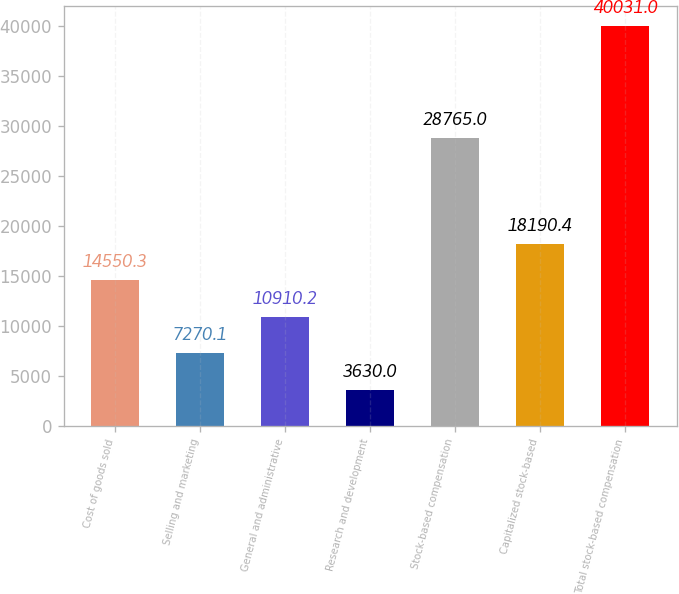Convert chart to OTSL. <chart><loc_0><loc_0><loc_500><loc_500><bar_chart><fcel>Cost of goods sold<fcel>Selling and marketing<fcel>General and administrative<fcel>Research and development<fcel>Stock-based compensation<fcel>Capitalized stock-based<fcel>Total stock-based compensation<nl><fcel>14550.3<fcel>7270.1<fcel>10910.2<fcel>3630<fcel>28765<fcel>18190.4<fcel>40031<nl></chart> 